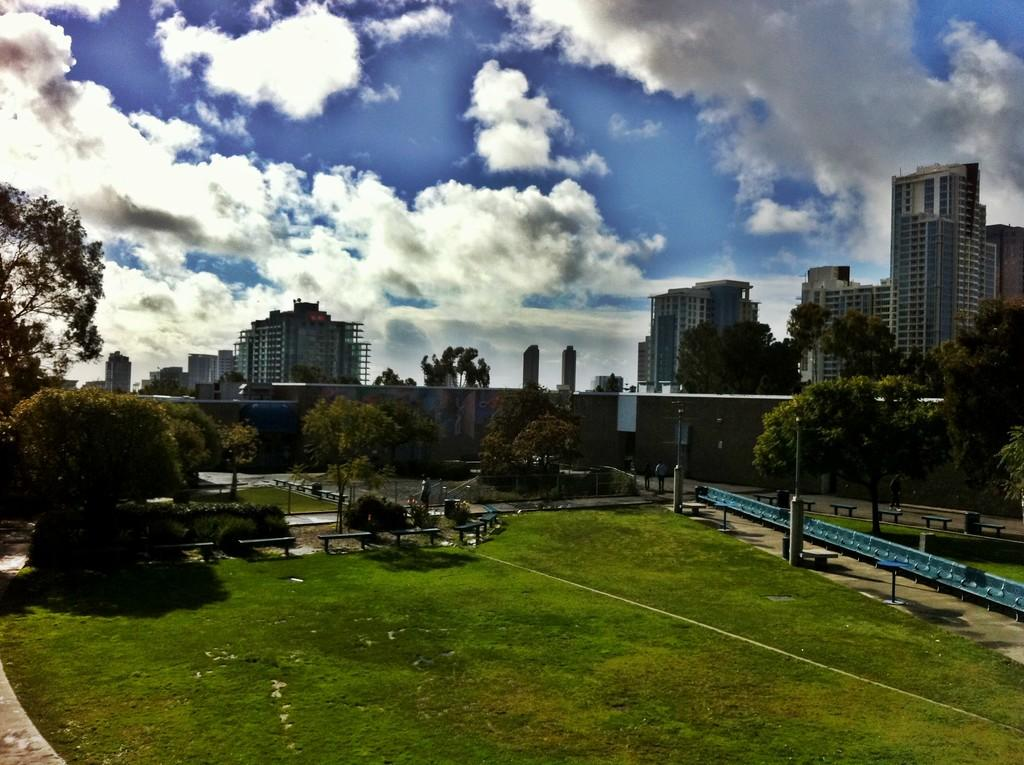What type of vegetation is present on the ground in the image? There is grass on the ground in the image. What other natural elements can be seen in the image? There are trees in the image. What man-made structures are visible in the image? There are buildings in the image. What is visible in the sky in the image? There are clouds in the sky in the image. What type of headwear is being worn by the trees in the image? There are no people or headwear present in the image; it features trees, buildings, grass, and clouds. How much income can be generated from the grass in the image? The image does not provide any information about the income generated from the grass, as it is a visual representation and not a financial document. 